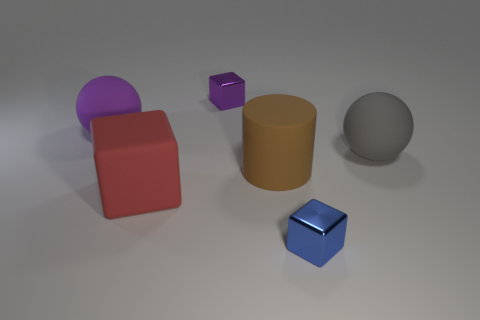What is the material of the tiny block behind the large sphere on the left side of the gray object?
Keep it short and to the point. Metal. The blue block that is made of the same material as the small purple block is what size?
Make the answer very short. Small. There is a purple thing that is in front of the purple block; what shape is it?
Your response must be concise. Sphere. There is a blue metal object that is the same shape as the large red matte object; what size is it?
Provide a short and direct response. Small. How many things are on the right side of the small object behind the large matte ball to the left of the cylinder?
Make the answer very short. 3. Is the number of rubber blocks in front of the large gray object the same as the number of brown shiny things?
Your response must be concise. No. What number of balls are big gray objects or red objects?
Keep it short and to the point. 1. Is the matte cylinder the same color as the large block?
Offer a terse response. No. Is the number of big purple matte things that are right of the purple metallic cube the same as the number of small blue blocks behind the brown rubber cylinder?
Ensure brevity in your answer.  Yes. What is the color of the rubber cylinder?
Provide a short and direct response. Brown. 